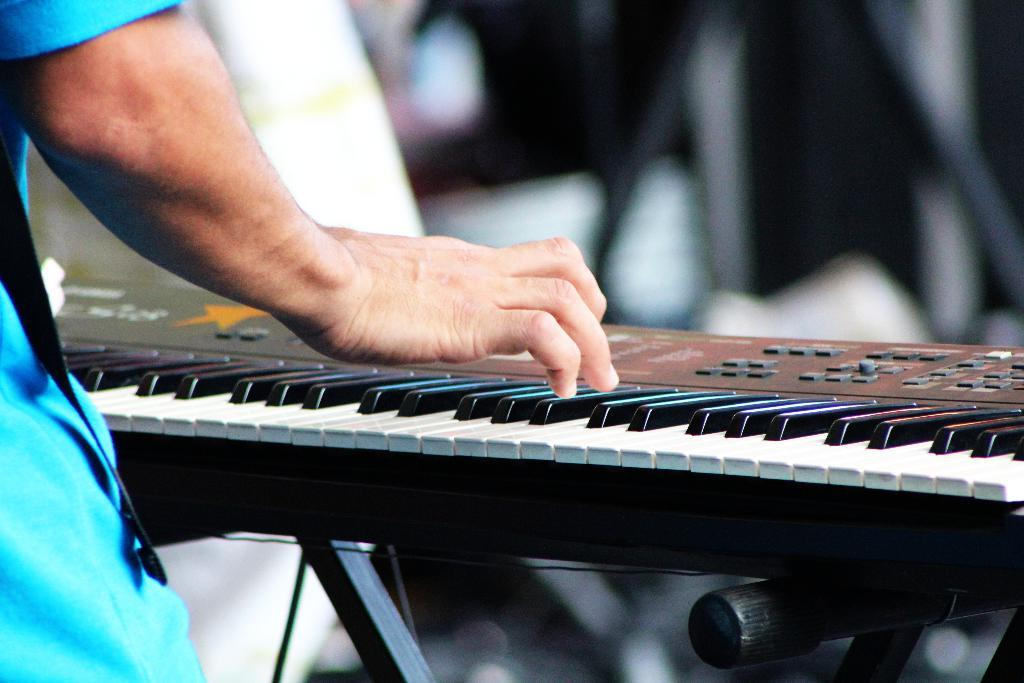What is the main subject of the image? There is a person in the image. What is the person doing in the image? The person is playing a piano. What type of sense is being used by the person to play the piano in the image? The image does not provide information about the sense being used by the person to play the piano. 